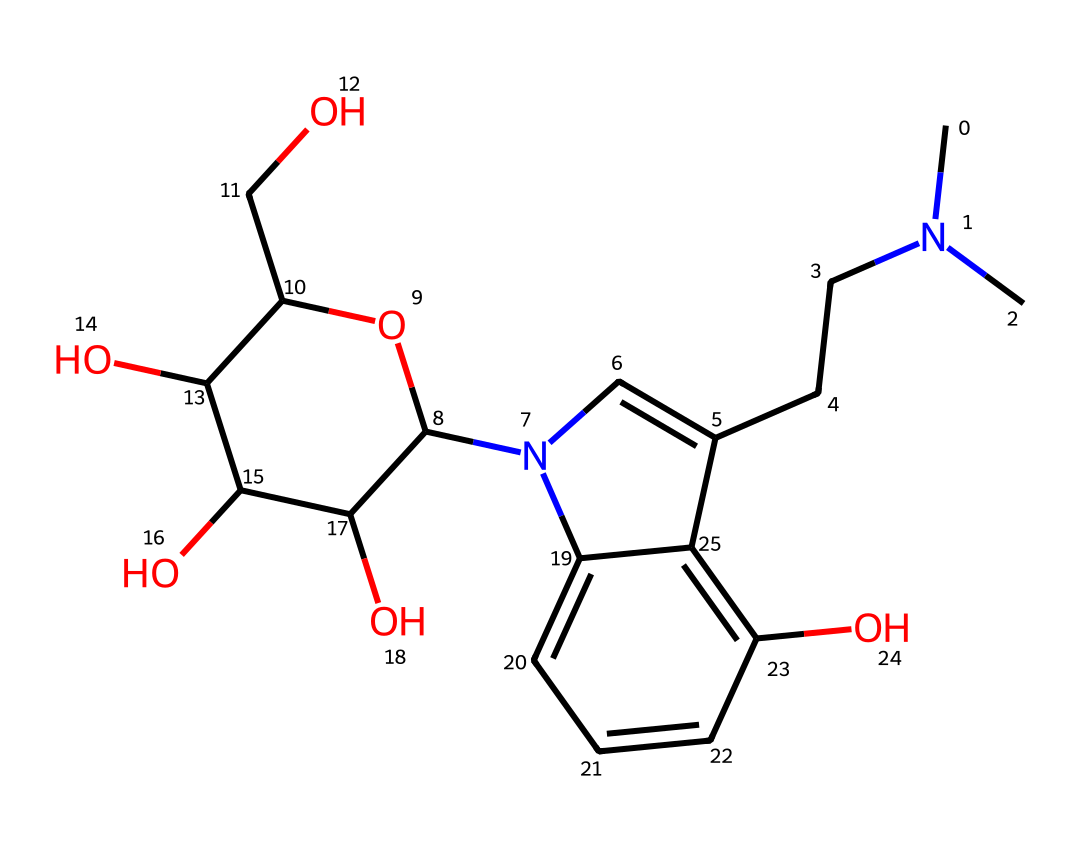What is the name of this chemical? The SMILES representation indicates that the chemical structure represents psilocybin, which is known as a psychedelic compound found in certain mushrooms.
Answer: psilocybin How many carbon atoms are present in this molecule? Count all the carbon atoms in the structure represented by the SMILES. The SMILES shows 17 carbon atoms in the complete structure.
Answer: 17 What type of functional group is present in psilocybin? The presence of the hydroxyl groups (-OH) in the structure indicates that psilocybin contains alcohol functional groups.
Answer: alcohol How many total nitrogen atoms are in this chemical? The SMILES shows there are two nitrogen atoms present in the structure, identifiable within the ring and side chains.
Answer: 2 Describe the molecular arrangement around the nitrogen atoms in psilocybin. The nitrogen atoms are part of a heterocyclic structure, indicating that they are integrated within rings, which typically enhances biological activity.
Answer: heterocyclic Which part of the psilocybin structure is responsible for its psychoactive effects? The indole ring system, which includes the nitrogen atoms and is part of the broader aromatic system, is usually linked to the psychoactive properties of compounds like psilocybin.
Answer: indole ring 